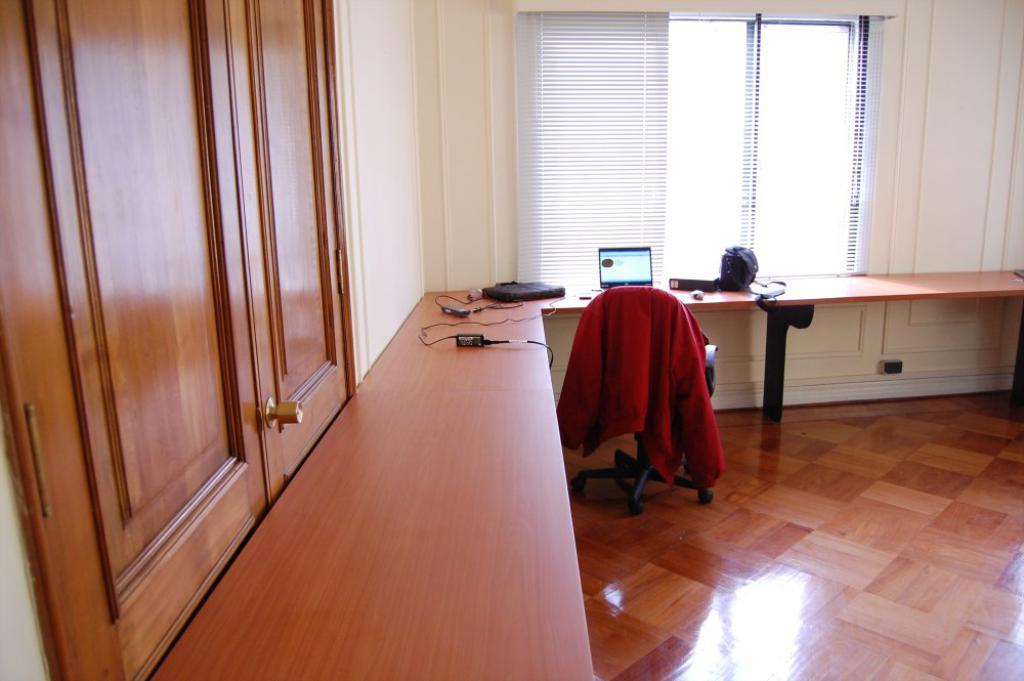What is located on the left side of the image? There are doors on the left side of the image. What electronic device can be seen on a table in the image? There is a laptop on a table in the image. What type of furniture is present in the image? There is a chair in the image. What type of window is visible in the image? There is a glass window with curtains in the image. Is there a boat visible in the image? No, there is no boat present in the image. How does the roof look like in the image? There is no mention of a roof in the provided facts, so we cannot answer this question. 